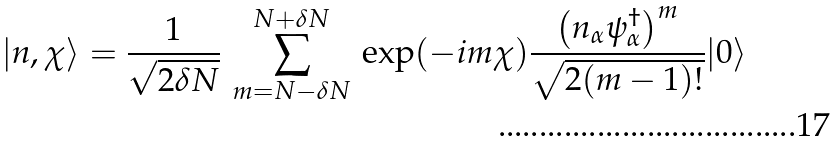<formula> <loc_0><loc_0><loc_500><loc_500>| { n } , \chi \rangle = \frac { 1 } { \sqrt { 2 \delta N } } \, \sum _ { m = N - \delta N } ^ { N + \delta N } \, \exp ( - i m \chi ) \frac { \left ( { n } _ { \alpha } \psi _ { \alpha } ^ { \dagger } \right ) ^ { m } } { \sqrt { 2 ( m - 1 ) ! } } | 0 \rangle</formula> 